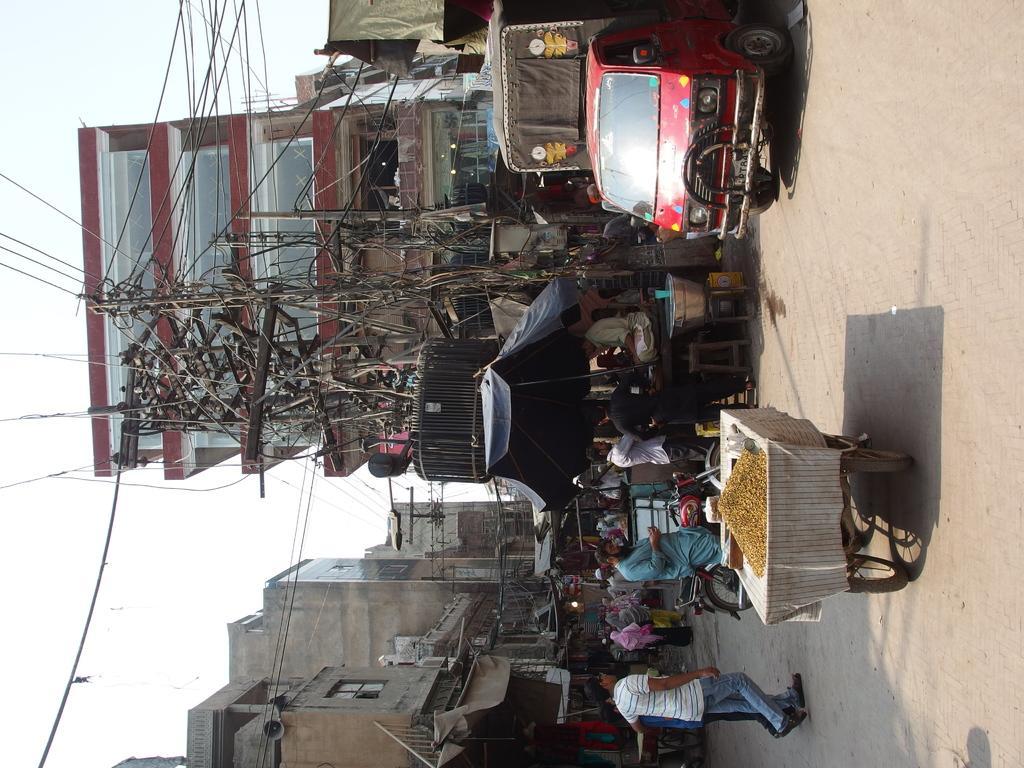How would you summarize this image in a sentence or two? There is a transformer,two poles and few wires and there are few people and vehicles in front of it and there are buildings in the background. 